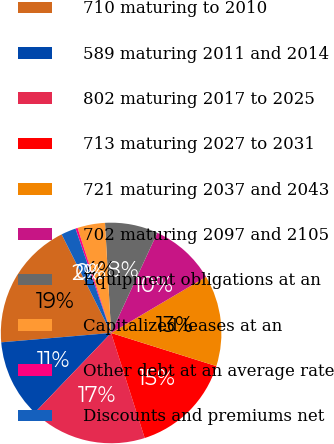<chart> <loc_0><loc_0><loc_500><loc_500><pie_chart><fcel>710 maturing to 2010<fcel>589 maturing 2011 and 2014<fcel>802 maturing 2017 to 2025<fcel>713 maturing 2027 to 2031<fcel>721 maturing 2037 and 2043<fcel>702 maturing 2097 and 2105<fcel>Equipment obligations at an<fcel>Capitalized leases at an<fcel>Other debt at an average rate<fcel>Discounts and premiums net<nl><fcel>18.95%<fcel>11.49%<fcel>17.08%<fcel>15.22%<fcel>13.35%<fcel>9.63%<fcel>7.76%<fcel>4.04%<fcel>0.31%<fcel>2.17%<nl></chart> 